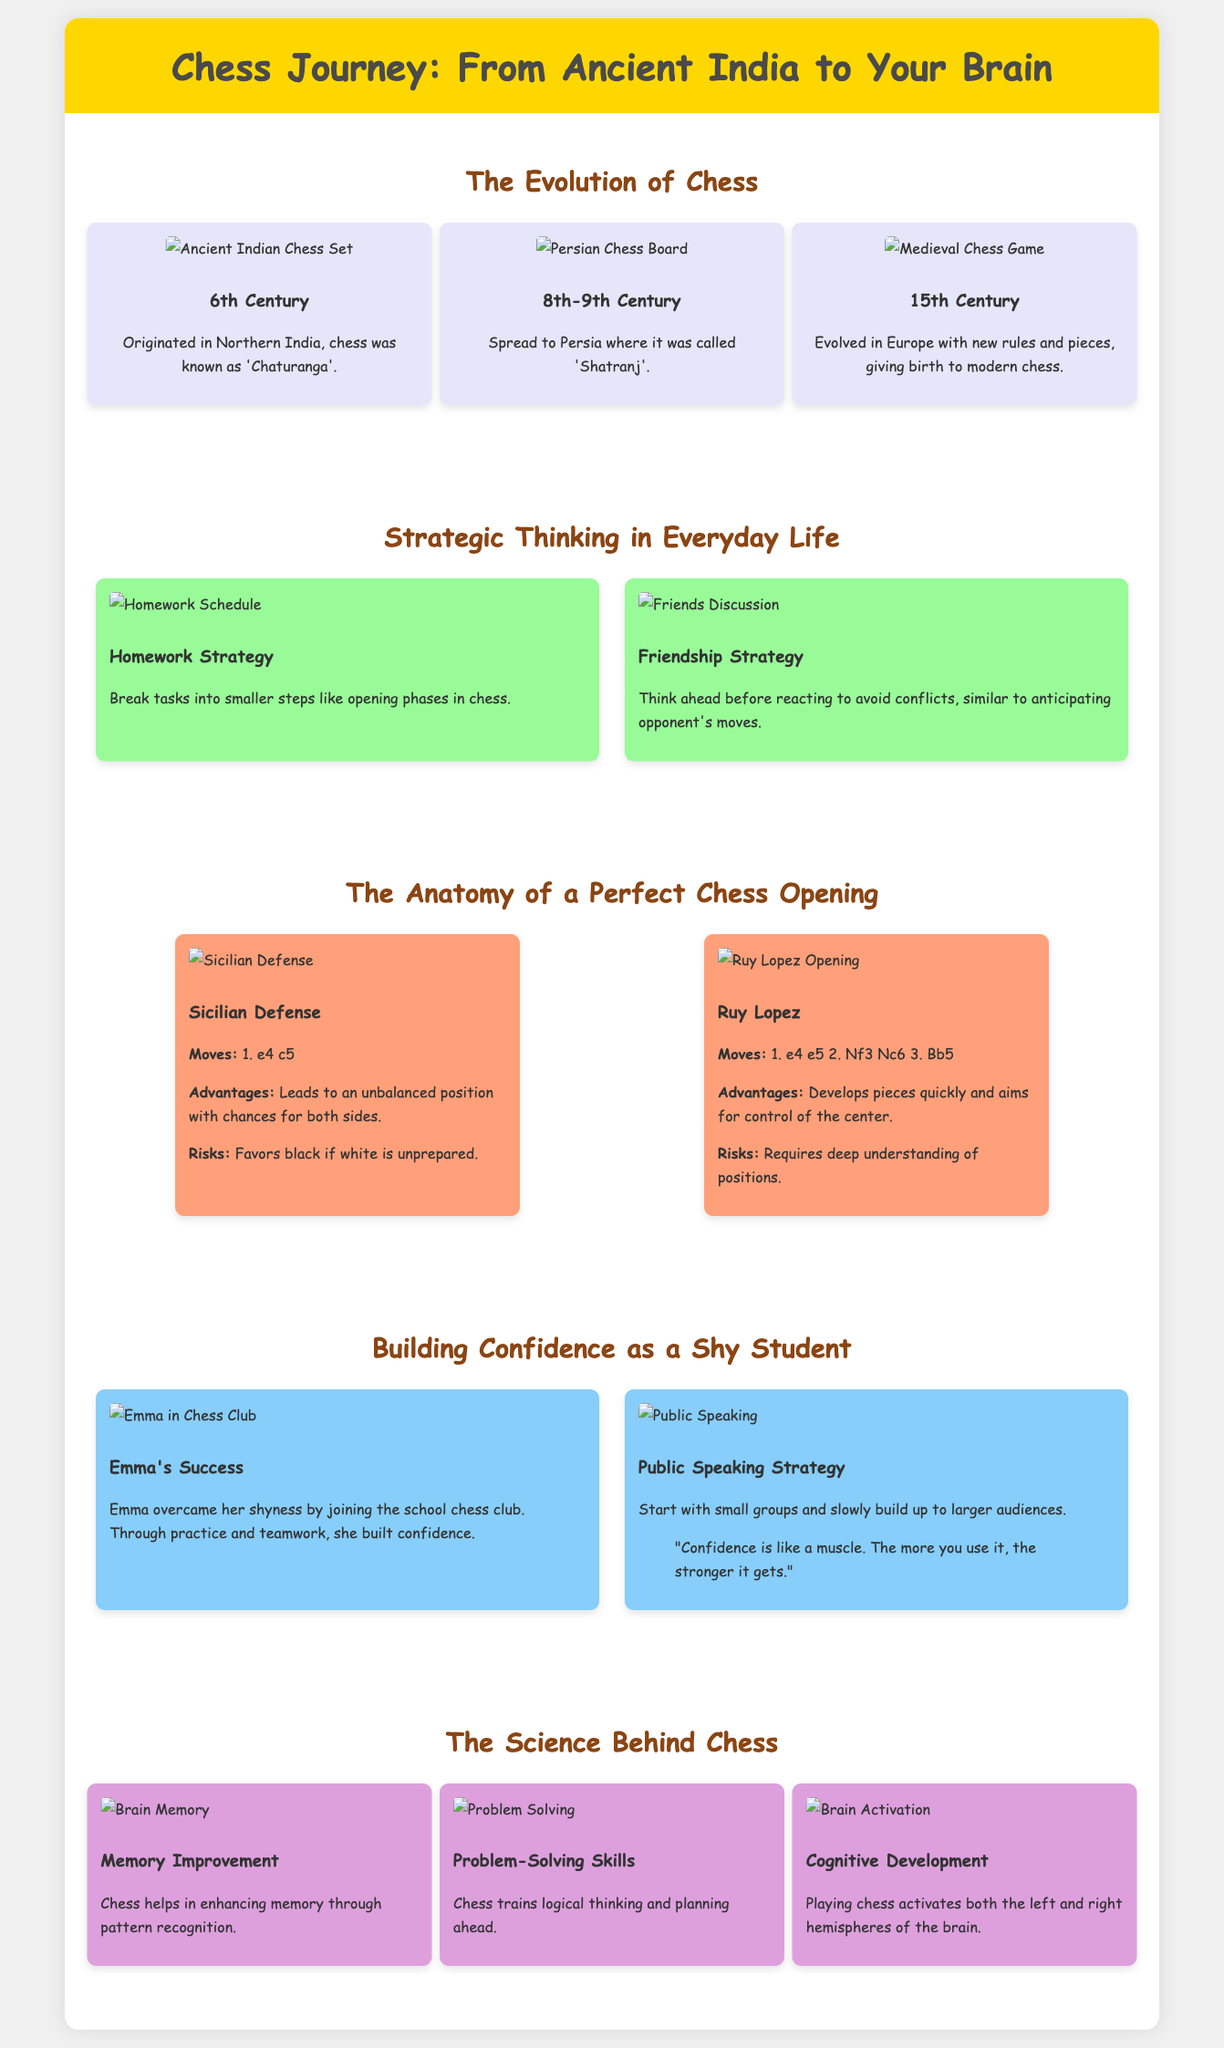What century did chess originate in India? The document states that chess originated in Northern India during the 6th Century.
Answer: 6th Century What is the name of the chess opening that starts with 1. e4 c5? The document lists the Sicilian Defense as the opening that starts with these moves.
Answer: Sicilian Defense Which student overcame shyness by joining the school chess club? Emma is mentioned in the document as the student who built confidence through joining the chess club.
Answer: Emma What cognitive benefit of playing chess is associated with pattern recognition? The document indicates that chess helps in enhancing memory through pattern recognition.
Answer: Memory Improvement In what century did chess evolve in Europe with new rules? Chess evolved in Europe with new rules in the 15th Century, as per the timeline in the document.
Answer: 15th Century What strategy is suggested for public speaking to shy students? The document recommends starting with small groups to build up confidence for public speaking.
Answer: Small groups What is one risk of the Ruy Lopez opening? The document mentions that the Ruy Lopez requires a deep understanding of positions as a risk.
Answer: Deep understanding of positions Which part of the brain is activated during a chess game? The document states that playing chess activates both the left and right hemispheres of the brain.
Answer: Both hemispheres What is the color of the background for the infographic? The background color of the infographic is specified as light gray (#f0f0f0) in the styles.
Answer: Light gray 